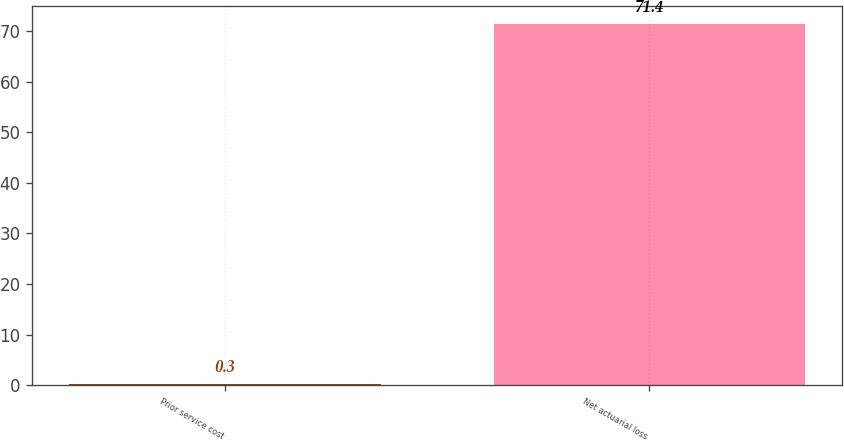Convert chart to OTSL. <chart><loc_0><loc_0><loc_500><loc_500><bar_chart><fcel>Prior service cost<fcel>Net actuarial loss<nl><fcel>0.3<fcel>71.4<nl></chart> 